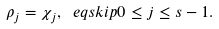Convert formula to latex. <formula><loc_0><loc_0><loc_500><loc_500>\rho _ { j } = \chi _ { j } , \ e q s k i p 0 \leq j \leq s - 1 .</formula> 